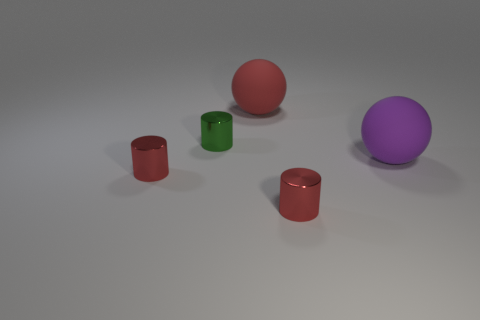Add 2 matte things. How many objects exist? 7 Subtract all cylinders. How many objects are left? 2 Add 1 small blue matte spheres. How many small blue matte spheres exist? 1 Subtract 0 blue cylinders. How many objects are left? 5 Subtract all big red matte objects. Subtract all cylinders. How many objects are left? 1 Add 4 red cylinders. How many red cylinders are left? 6 